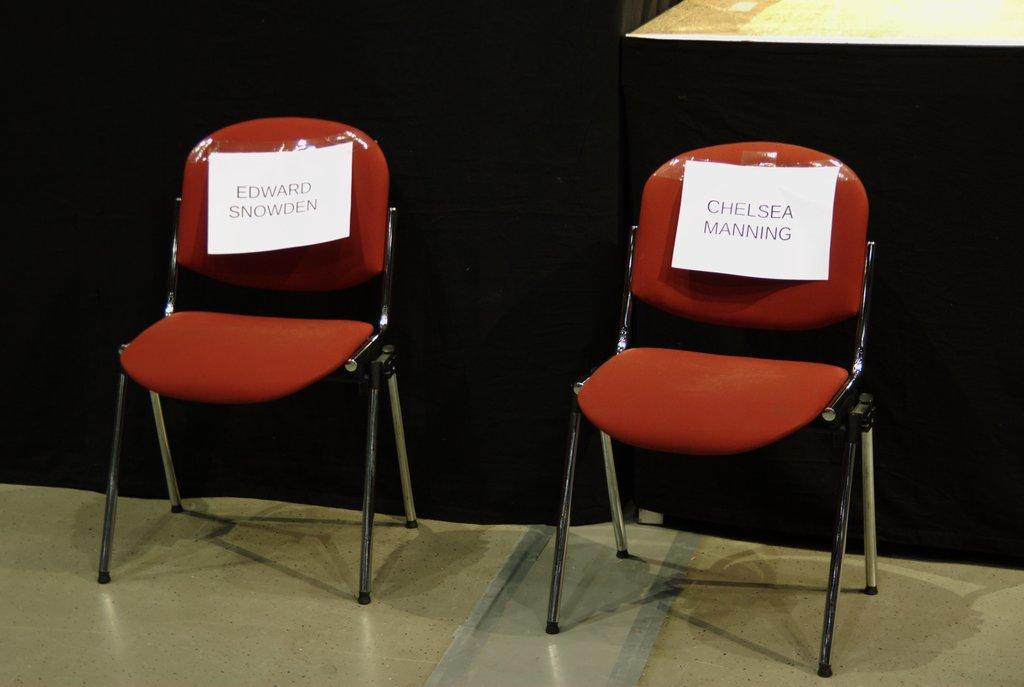In one or two sentences, can you explain what this image depicts? In this image there are two chairs, there are papers on the chairs, there is text on the papers, there is floor towards the bottom of the image, there is an object towards the top of the image, at the background of the image there is a black colored cloth. 